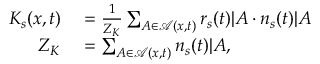Convert formula to latex. <formula><loc_0><loc_0><loc_500><loc_500>\begin{array} { r l } { K _ { s } ( x , t ) } & = \frac { 1 } { Z _ { K } } \sum _ { A \in \mathcal { A } ( x , t ) } r _ { s } ( t ) | A \cdot n _ { s } ( t ) | A } \\ { Z _ { K } } & = \sum _ { A \in \mathcal { A } ( x , t ) } n _ { s } ( t ) | A , } \end{array}</formula> 